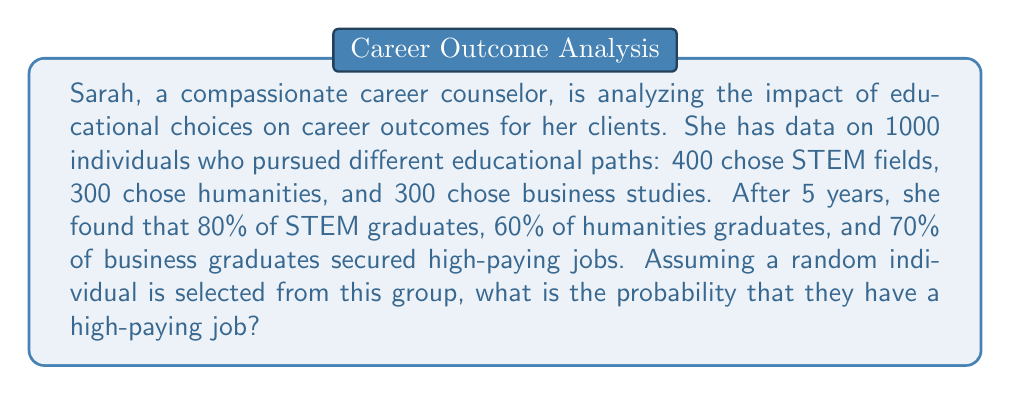What is the answer to this math problem? Let's approach this step-by-step using the law of total probability:

1) Define events:
   A: The individual has a high-paying job
   S: The individual studied STEM
   H: The individual studied humanities
   B: The individual studied business

2) We know:
   P(S) = 400/1000 = 0.4
   P(H) = 300/1000 = 0.3
   P(B) = 300/1000 = 0.3
   P(A|S) = 0.8
   P(A|H) = 0.6
   P(A|B) = 0.7

3) The law of total probability states:
   $$P(A) = P(A|S)P(S) + P(A|H)P(H) + P(A|B)P(B)$$

4) Substituting the values:
   $$P(A) = (0.8)(0.4) + (0.6)(0.3) + (0.7)(0.3)$$

5) Calculating:
   $$P(A) = 0.32 + 0.18 + 0.21 = 0.71$$

Therefore, the probability that a randomly selected individual from this group has a high-paying job is 0.71 or 71%.
Answer: 0.71 